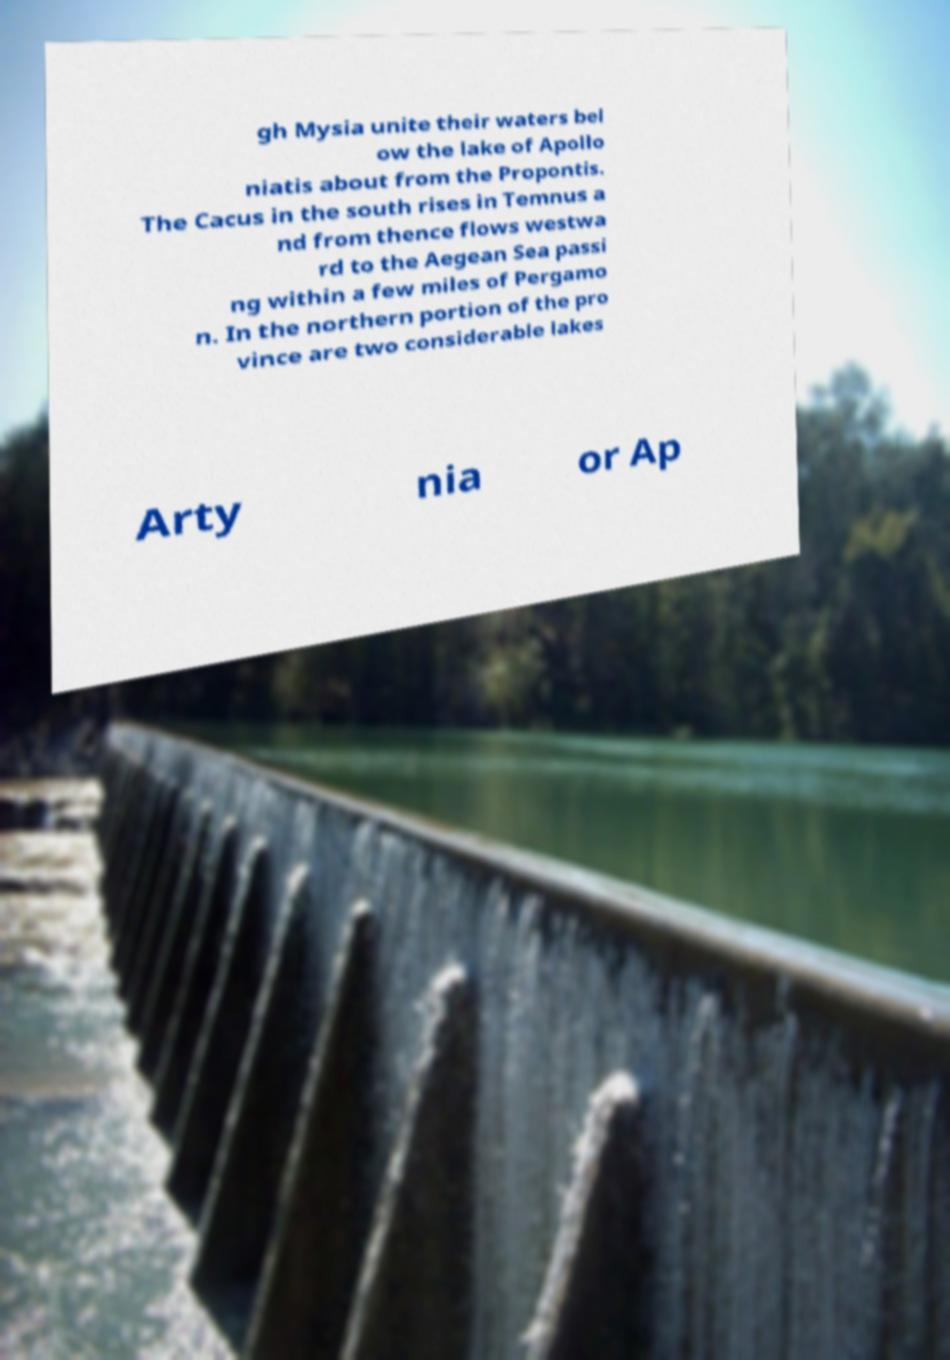There's text embedded in this image that I need extracted. Can you transcribe it verbatim? gh Mysia unite their waters bel ow the lake of Apollo niatis about from the Propontis. The Cacus in the south rises in Temnus a nd from thence flows westwa rd to the Aegean Sea passi ng within a few miles of Pergamo n. In the northern portion of the pro vince are two considerable lakes Arty nia or Ap 